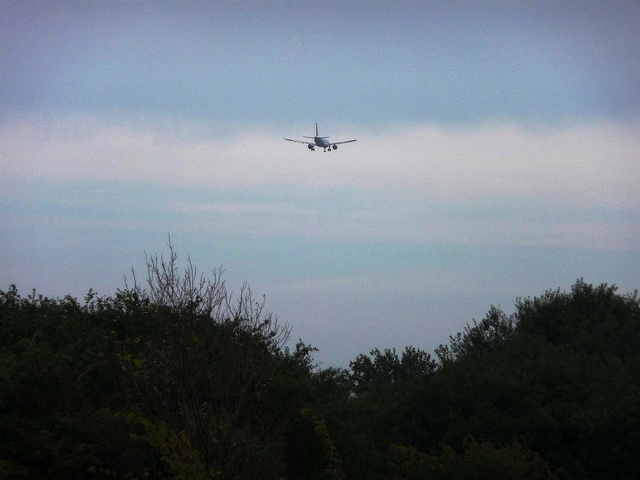Describe the objects in this image and their specific colors. I can see a airplane in gray, darkgray, and lightgray tones in this image. 